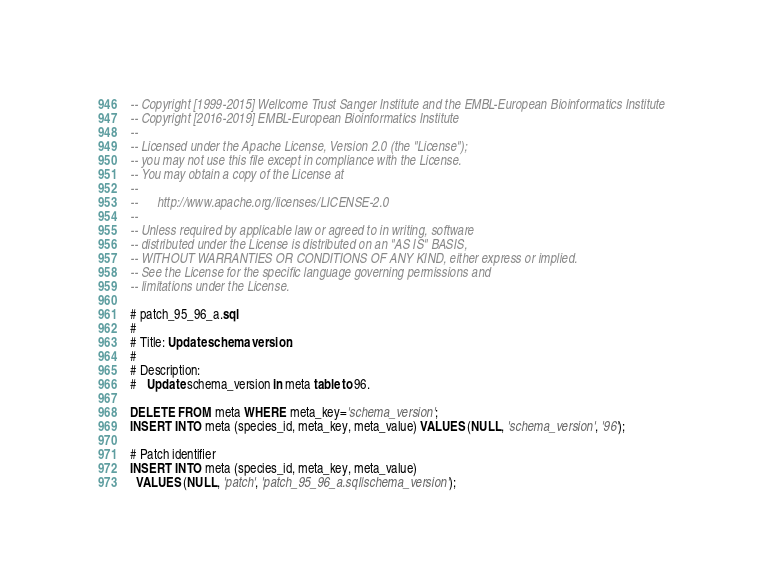<code> <loc_0><loc_0><loc_500><loc_500><_SQL_>-- Copyright [1999-2015] Wellcome Trust Sanger Institute and the EMBL-European Bioinformatics Institute
-- Copyright [2016-2019] EMBL-European Bioinformatics Institute
-- 
-- Licensed under the Apache License, Version 2.0 (the "License");
-- you may not use this file except in compliance with the License.
-- You may obtain a copy of the License at
-- 
--      http://www.apache.org/licenses/LICENSE-2.0
-- 
-- Unless required by applicable law or agreed to in writing, software
-- distributed under the License is distributed on an "AS IS" BASIS,
-- WITHOUT WARRANTIES OR CONDITIONS OF ANY KIND, either express or implied.
-- See the License for the specific language governing permissions and
-- limitations under the License.

# patch_95_96_a.sql
#
# Title: Update schema version.
#
# Description:
#   Update schema_version in meta table to 96.

DELETE FROM meta WHERE meta_key='schema_version';
INSERT INTO meta (species_id, meta_key, meta_value) VALUES (NULL, 'schema_version', '96');

# Patch identifier
INSERT INTO meta (species_id, meta_key, meta_value)
  VALUES (NULL, 'patch', 'patch_95_96_a.sql|schema_version');
</code> 